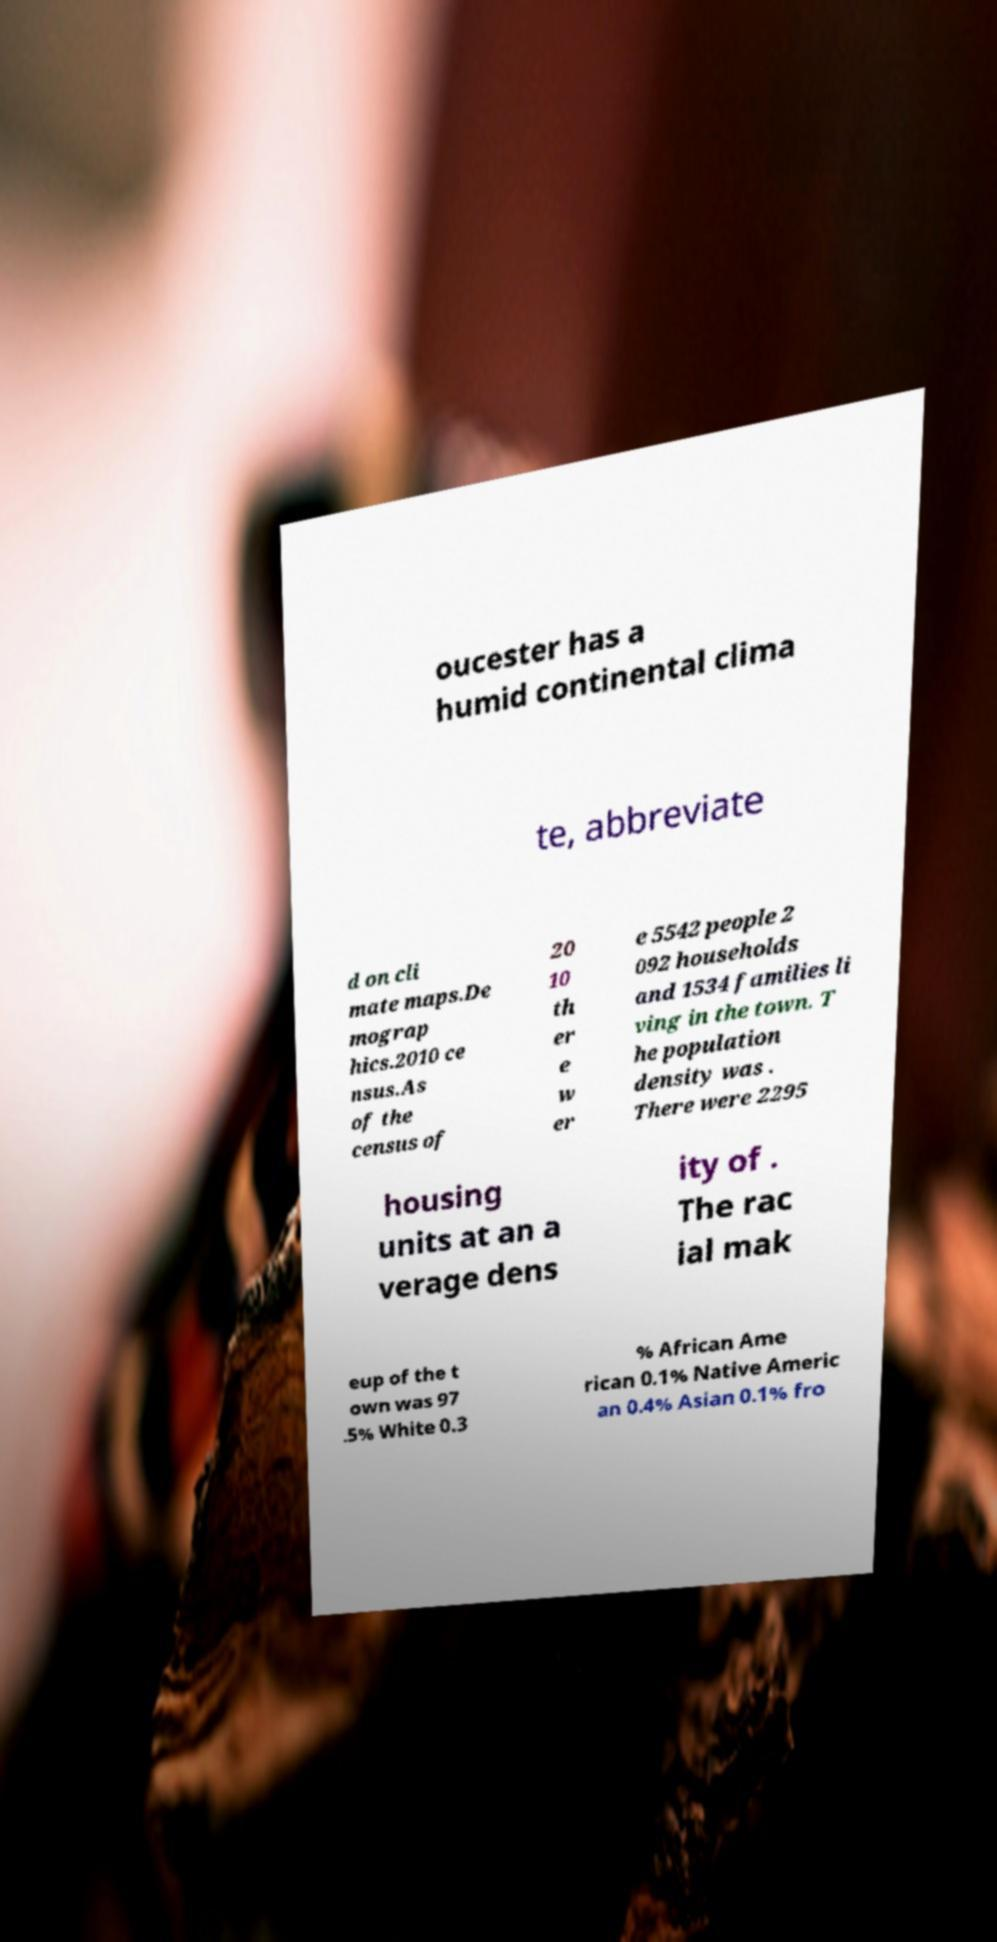What messages or text are displayed in this image? I need them in a readable, typed format. oucester has a humid continental clima te, abbreviate d on cli mate maps.De mograp hics.2010 ce nsus.As of the census of 20 10 th er e w er e 5542 people 2 092 households and 1534 families li ving in the town. T he population density was . There were 2295 housing units at an a verage dens ity of . The rac ial mak eup of the t own was 97 .5% White 0.3 % African Ame rican 0.1% Native Americ an 0.4% Asian 0.1% fro 